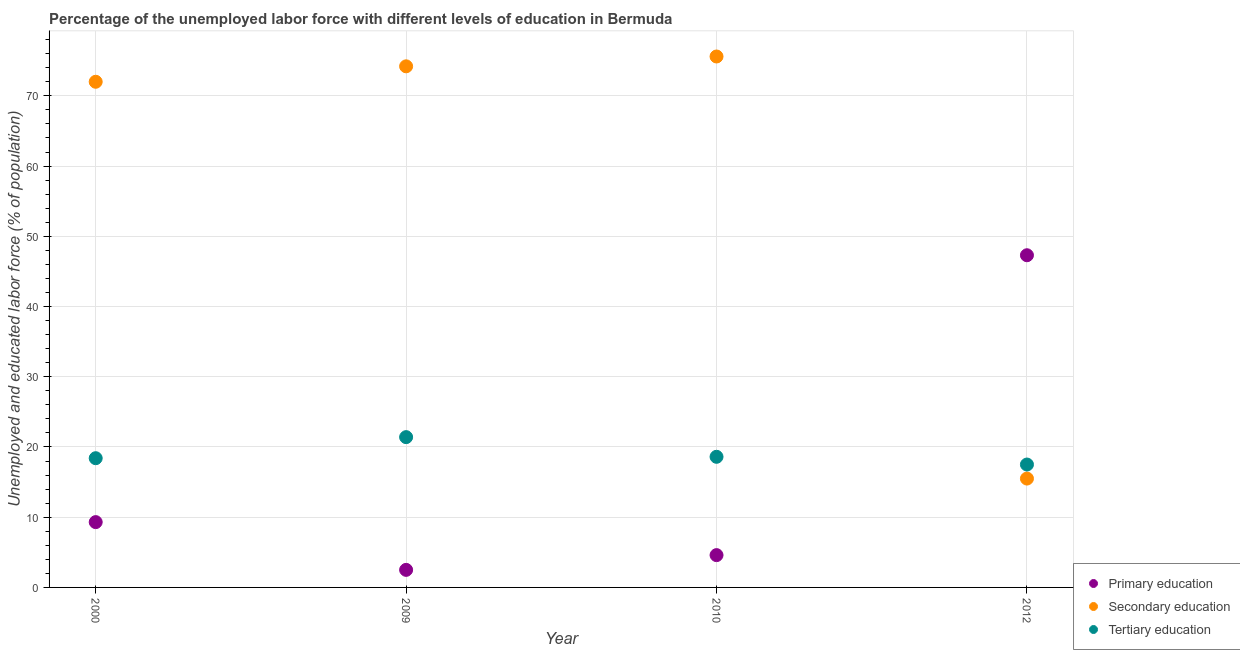Is the number of dotlines equal to the number of legend labels?
Your answer should be very brief. Yes. Across all years, what is the maximum percentage of labor force who received tertiary education?
Make the answer very short. 21.4. Across all years, what is the minimum percentage of labor force who received tertiary education?
Give a very brief answer. 17.5. What is the total percentage of labor force who received secondary education in the graph?
Provide a succinct answer. 237.3. What is the difference between the percentage of labor force who received primary education in 2009 and that in 2012?
Offer a terse response. -44.8. What is the difference between the percentage of labor force who received secondary education in 2010 and the percentage of labor force who received primary education in 2009?
Your response must be concise. 73.1. What is the average percentage of labor force who received tertiary education per year?
Your answer should be compact. 18.97. In the year 2009, what is the difference between the percentage of labor force who received primary education and percentage of labor force who received tertiary education?
Give a very brief answer. -18.9. What is the ratio of the percentage of labor force who received primary education in 2000 to that in 2009?
Your answer should be very brief. 3.72. Is the percentage of labor force who received primary education in 2000 less than that in 2012?
Your response must be concise. Yes. Is the difference between the percentage of labor force who received secondary education in 2009 and 2012 greater than the difference between the percentage of labor force who received primary education in 2009 and 2012?
Keep it short and to the point. Yes. What is the difference between the highest and the second highest percentage of labor force who received tertiary education?
Your response must be concise. 2.8. What is the difference between the highest and the lowest percentage of labor force who received primary education?
Provide a succinct answer. 44.8. In how many years, is the percentage of labor force who received primary education greater than the average percentage of labor force who received primary education taken over all years?
Your answer should be compact. 1. Is it the case that in every year, the sum of the percentage of labor force who received primary education and percentage of labor force who received secondary education is greater than the percentage of labor force who received tertiary education?
Provide a succinct answer. Yes. Is the percentage of labor force who received tertiary education strictly greater than the percentage of labor force who received secondary education over the years?
Your answer should be very brief. No. Is the percentage of labor force who received primary education strictly less than the percentage of labor force who received secondary education over the years?
Your answer should be very brief. No. How many years are there in the graph?
Your answer should be compact. 4. Are the values on the major ticks of Y-axis written in scientific E-notation?
Provide a succinct answer. No. Where does the legend appear in the graph?
Your answer should be very brief. Bottom right. How many legend labels are there?
Your answer should be very brief. 3. How are the legend labels stacked?
Your answer should be very brief. Vertical. What is the title of the graph?
Your answer should be very brief. Percentage of the unemployed labor force with different levels of education in Bermuda. Does "Ages 20-60" appear as one of the legend labels in the graph?
Make the answer very short. No. What is the label or title of the Y-axis?
Your answer should be compact. Unemployed and educated labor force (% of population). What is the Unemployed and educated labor force (% of population) in Primary education in 2000?
Your answer should be very brief. 9.3. What is the Unemployed and educated labor force (% of population) in Tertiary education in 2000?
Keep it short and to the point. 18.4. What is the Unemployed and educated labor force (% of population) in Primary education in 2009?
Your answer should be compact. 2.5. What is the Unemployed and educated labor force (% of population) in Secondary education in 2009?
Your answer should be compact. 74.2. What is the Unemployed and educated labor force (% of population) in Tertiary education in 2009?
Make the answer very short. 21.4. What is the Unemployed and educated labor force (% of population) in Primary education in 2010?
Your response must be concise. 4.6. What is the Unemployed and educated labor force (% of population) in Secondary education in 2010?
Your answer should be compact. 75.6. What is the Unemployed and educated labor force (% of population) in Tertiary education in 2010?
Keep it short and to the point. 18.6. What is the Unemployed and educated labor force (% of population) of Primary education in 2012?
Provide a succinct answer. 47.3. Across all years, what is the maximum Unemployed and educated labor force (% of population) in Primary education?
Give a very brief answer. 47.3. Across all years, what is the maximum Unemployed and educated labor force (% of population) of Secondary education?
Make the answer very short. 75.6. Across all years, what is the maximum Unemployed and educated labor force (% of population) in Tertiary education?
Offer a very short reply. 21.4. What is the total Unemployed and educated labor force (% of population) of Primary education in the graph?
Keep it short and to the point. 63.7. What is the total Unemployed and educated labor force (% of population) of Secondary education in the graph?
Provide a short and direct response. 237.3. What is the total Unemployed and educated labor force (% of population) in Tertiary education in the graph?
Offer a terse response. 75.9. What is the difference between the Unemployed and educated labor force (% of population) of Tertiary education in 2000 and that in 2009?
Your answer should be compact. -3. What is the difference between the Unemployed and educated labor force (% of population) in Secondary education in 2000 and that in 2010?
Provide a short and direct response. -3.6. What is the difference between the Unemployed and educated labor force (% of population) in Primary education in 2000 and that in 2012?
Keep it short and to the point. -38. What is the difference between the Unemployed and educated labor force (% of population) of Secondary education in 2000 and that in 2012?
Provide a short and direct response. 56.5. What is the difference between the Unemployed and educated labor force (% of population) of Primary education in 2009 and that in 2010?
Provide a succinct answer. -2.1. What is the difference between the Unemployed and educated labor force (% of population) in Secondary education in 2009 and that in 2010?
Provide a succinct answer. -1.4. What is the difference between the Unemployed and educated labor force (% of population) of Primary education in 2009 and that in 2012?
Offer a terse response. -44.8. What is the difference between the Unemployed and educated labor force (% of population) in Secondary education in 2009 and that in 2012?
Offer a terse response. 58.7. What is the difference between the Unemployed and educated labor force (% of population) of Primary education in 2010 and that in 2012?
Make the answer very short. -42.7. What is the difference between the Unemployed and educated labor force (% of population) in Secondary education in 2010 and that in 2012?
Ensure brevity in your answer.  60.1. What is the difference between the Unemployed and educated labor force (% of population) of Tertiary education in 2010 and that in 2012?
Make the answer very short. 1.1. What is the difference between the Unemployed and educated labor force (% of population) in Primary education in 2000 and the Unemployed and educated labor force (% of population) in Secondary education in 2009?
Offer a terse response. -64.9. What is the difference between the Unemployed and educated labor force (% of population) of Primary education in 2000 and the Unemployed and educated labor force (% of population) of Tertiary education in 2009?
Ensure brevity in your answer.  -12.1. What is the difference between the Unemployed and educated labor force (% of population) of Secondary education in 2000 and the Unemployed and educated labor force (% of population) of Tertiary education in 2009?
Give a very brief answer. 50.6. What is the difference between the Unemployed and educated labor force (% of population) of Primary education in 2000 and the Unemployed and educated labor force (% of population) of Secondary education in 2010?
Give a very brief answer. -66.3. What is the difference between the Unemployed and educated labor force (% of population) of Secondary education in 2000 and the Unemployed and educated labor force (% of population) of Tertiary education in 2010?
Make the answer very short. 53.4. What is the difference between the Unemployed and educated labor force (% of population) in Primary education in 2000 and the Unemployed and educated labor force (% of population) in Tertiary education in 2012?
Make the answer very short. -8.2. What is the difference between the Unemployed and educated labor force (% of population) of Secondary education in 2000 and the Unemployed and educated labor force (% of population) of Tertiary education in 2012?
Keep it short and to the point. 54.5. What is the difference between the Unemployed and educated labor force (% of population) in Primary education in 2009 and the Unemployed and educated labor force (% of population) in Secondary education in 2010?
Ensure brevity in your answer.  -73.1. What is the difference between the Unemployed and educated labor force (% of population) of Primary education in 2009 and the Unemployed and educated labor force (% of population) of Tertiary education in 2010?
Give a very brief answer. -16.1. What is the difference between the Unemployed and educated labor force (% of population) in Secondary education in 2009 and the Unemployed and educated labor force (% of population) in Tertiary education in 2010?
Give a very brief answer. 55.6. What is the difference between the Unemployed and educated labor force (% of population) of Primary education in 2009 and the Unemployed and educated labor force (% of population) of Secondary education in 2012?
Keep it short and to the point. -13. What is the difference between the Unemployed and educated labor force (% of population) of Secondary education in 2009 and the Unemployed and educated labor force (% of population) of Tertiary education in 2012?
Ensure brevity in your answer.  56.7. What is the difference between the Unemployed and educated labor force (% of population) in Primary education in 2010 and the Unemployed and educated labor force (% of population) in Secondary education in 2012?
Make the answer very short. -10.9. What is the difference between the Unemployed and educated labor force (% of population) in Primary education in 2010 and the Unemployed and educated labor force (% of population) in Tertiary education in 2012?
Ensure brevity in your answer.  -12.9. What is the difference between the Unemployed and educated labor force (% of population) of Secondary education in 2010 and the Unemployed and educated labor force (% of population) of Tertiary education in 2012?
Ensure brevity in your answer.  58.1. What is the average Unemployed and educated labor force (% of population) of Primary education per year?
Provide a succinct answer. 15.93. What is the average Unemployed and educated labor force (% of population) of Secondary education per year?
Provide a succinct answer. 59.33. What is the average Unemployed and educated labor force (% of population) in Tertiary education per year?
Your answer should be very brief. 18.98. In the year 2000, what is the difference between the Unemployed and educated labor force (% of population) in Primary education and Unemployed and educated labor force (% of population) in Secondary education?
Your answer should be very brief. -62.7. In the year 2000, what is the difference between the Unemployed and educated labor force (% of population) of Primary education and Unemployed and educated labor force (% of population) of Tertiary education?
Provide a short and direct response. -9.1. In the year 2000, what is the difference between the Unemployed and educated labor force (% of population) in Secondary education and Unemployed and educated labor force (% of population) in Tertiary education?
Keep it short and to the point. 53.6. In the year 2009, what is the difference between the Unemployed and educated labor force (% of population) of Primary education and Unemployed and educated labor force (% of population) of Secondary education?
Offer a very short reply. -71.7. In the year 2009, what is the difference between the Unemployed and educated labor force (% of population) in Primary education and Unemployed and educated labor force (% of population) in Tertiary education?
Your answer should be compact. -18.9. In the year 2009, what is the difference between the Unemployed and educated labor force (% of population) of Secondary education and Unemployed and educated labor force (% of population) of Tertiary education?
Provide a short and direct response. 52.8. In the year 2010, what is the difference between the Unemployed and educated labor force (% of population) of Primary education and Unemployed and educated labor force (% of population) of Secondary education?
Provide a short and direct response. -71. In the year 2010, what is the difference between the Unemployed and educated labor force (% of population) of Primary education and Unemployed and educated labor force (% of population) of Tertiary education?
Give a very brief answer. -14. In the year 2010, what is the difference between the Unemployed and educated labor force (% of population) of Secondary education and Unemployed and educated labor force (% of population) of Tertiary education?
Make the answer very short. 57. In the year 2012, what is the difference between the Unemployed and educated labor force (% of population) in Primary education and Unemployed and educated labor force (% of population) in Secondary education?
Make the answer very short. 31.8. In the year 2012, what is the difference between the Unemployed and educated labor force (% of population) of Primary education and Unemployed and educated labor force (% of population) of Tertiary education?
Provide a succinct answer. 29.8. In the year 2012, what is the difference between the Unemployed and educated labor force (% of population) in Secondary education and Unemployed and educated labor force (% of population) in Tertiary education?
Your answer should be very brief. -2. What is the ratio of the Unemployed and educated labor force (% of population) of Primary education in 2000 to that in 2009?
Provide a short and direct response. 3.72. What is the ratio of the Unemployed and educated labor force (% of population) in Secondary education in 2000 to that in 2009?
Provide a short and direct response. 0.97. What is the ratio of the Unemployed and educated labor force (% of population) in Tertiary education in 2000 to that in 2009?
Offer a very short reply. 0.86. What is the ratio of the Unemployed and educated labor force (% of population) in Primary education in 2000 to that in 2010?
Your answer should be compact. 2.02. What is the ratio of the Unemployed and educated labor force (% of population) of Secondary education in 2000 to that in 2010?
Your answer should be very brief. 0.95. What is the ratio of the Unemployed and educated labor force (% of population) in Primary education in 2000 to that in 2012?
Provide a short and direct response. 0.2. What is the ratio of the Unemployed and educated labor force (% of population) in Secondary education in 2000 to that in 2012?
Your response must be concise. 4.65. What is the ratio of the Unemployed and educated labor force (% of population) of Tertiary education in 2000 to that in 2012?
Give a very brief answer. 1.05. What is the ratio of the Unemployed and educated labor force (% of population) in Primary education in 2009 to that in 2010?
Your answer should be very brief. 0.54. What is the ratio of the Unemployed and educated labor force (% of population) of Secondary education in 2009 to that in 2010?
Your response must be concise. 0.98. What is the ratio of the Unemployed and educated labor force (% of population) in Tertiary education in 2009 to that in 2010?
Your answer should be very brief. 1.15. What is the ratio of the Unemployed and educated labor force (% of population) in Primary education in 2009 to that in 2012?
Keep it short and to the point. 0.05. What is the ratio of the Unemployed and educated labor force (% of population) of Secondary education in 2009 to that in 2012?
Give a very brief answer. 4.79. What is the ratio of the Unemployed and educated labor force (% of population) in Tertiary education in 2009 to that in 2012?
Offer a very short reply. 1.22. What is the ratio of the Unemployed and educated labor force (% of population) of Primary education in 2010 to that in 2012?
Offer a very short reply. 0.1. What is the ratio of the Unemployed and educated labor force (% of population) of Secondary education in 2010 to that in 2012?
Ensure brevity in your answer.  4.88. What is the ratio of the Unemployed and educated labor force (% of population) of Tertiary education in 2010 to that in 2012?
Provide a short and direct response. 1.06. What is the difference between the highest and the second highest Unemployed and educated labor force (% of population) in Tertiary education?
Keep it short and to the point. 2.8. What is the difference between the highest and the lowest Unemployed and educated labor force (% of population) of Primary education?
Ensure brevity in your answer.  44.8. What is the difference between the highest and the lowest Unemployed and educated labor force (% of population) in Secondary education?
Provide a short and direct response. 60.1. What is the difference between the highest and the lowest Unemployed and educated labor force (% of population) of Tertiary education?
Your response must be concise. 3.9. 